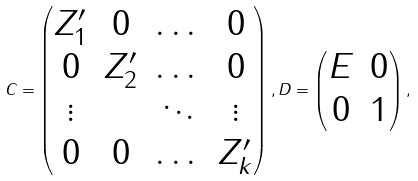<formula> <loc_0><loc_0><loc_500><loc_500>C = \begin{pmatrix} Z _ { 1 } ^ { \prime } & 0 & \dots & 0 \\ 0 & Z _ { 2 } ^ { \prime } & \dots & 0 \\ \vdots & & \ddots & \vdots \\ 0 & 0 & \dots & Z _ { k } ^ { \prime } \\ \end{pmatrix} , D = \begin{pmatrix} E & 0 \\ 0 & 1 \end{pmatrix} ,</formula> 